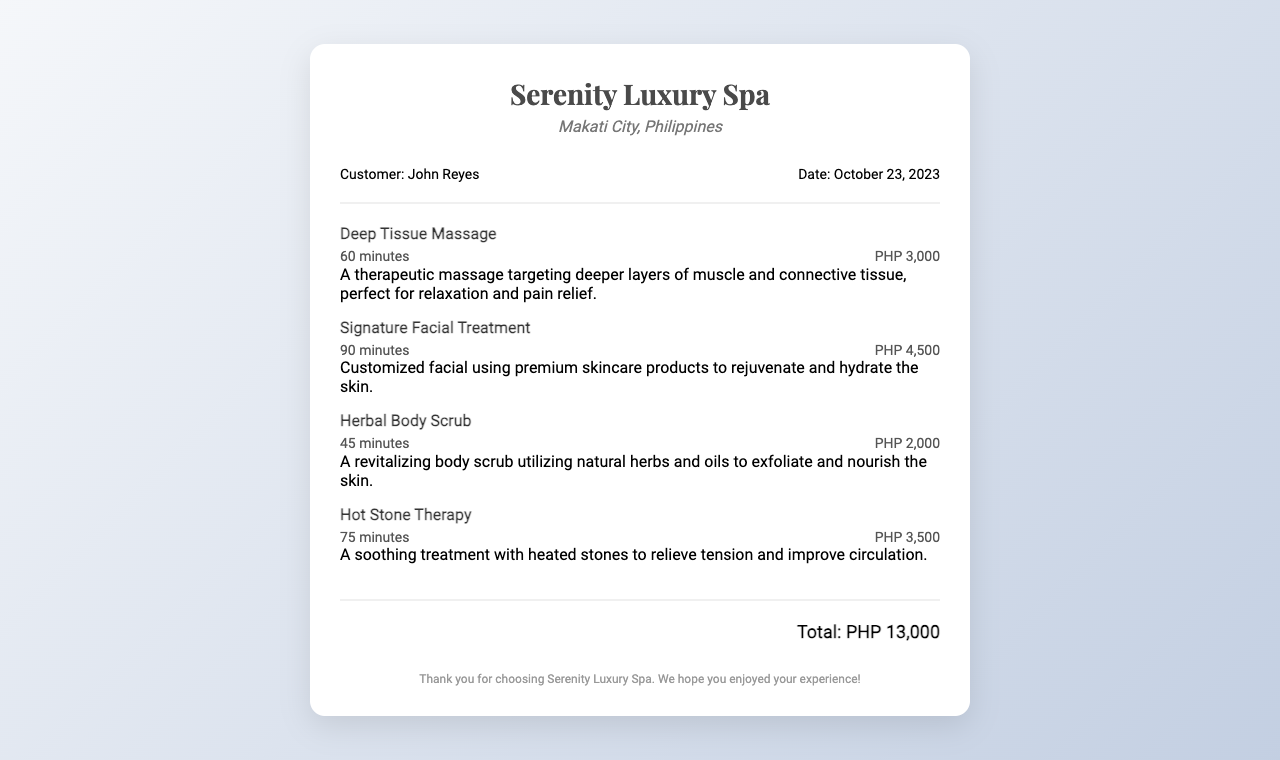What is the name of the spa? The name of the spa is stated at the top of the receipt, which is "Serenity Luxury Spa."
Answer: Serenity Luxury Spa Who is the customer? The customer's name is provided in the customer information section, which is "John Reyes."
Answer: John Reyes What date is on the receipt? The date is listed in the customer information section, which is "October 23, 2023."
Answer: October 23, 2023 What is the duration of the Deep Tissue Massage? The duration for the Deep Tissue Massage is specified in the service details, which is "60 minutes."
Answer: 60 minutes What is the total charge for the services rendered? The total charge is clearly mentioned at the bottom of the receipt, stated as "Total: PHP 13,000."
Answer: PHP 13,000 What is the price of the Signature Facial Treatment? The price for the Signature Facial Treatment is included in the service details, which is "PHP 4,500."
Answer: PHP 4,500 How many services are listed on the receipt? The number of service entries can be counted from the services section, which shows four distinct services.
Answer: 4 Which service has the longest duration? By comparing the durations, the service with the longest duration is the Signature Facial Treatment, which is "90 minutes."
Answer: Signature Facial Treatment What type of treatment includes heated stones? The treatment that includes heated stones is specifically mentioned as "Hot Stone Therapy."
Answer: Hot Stone Therapy 